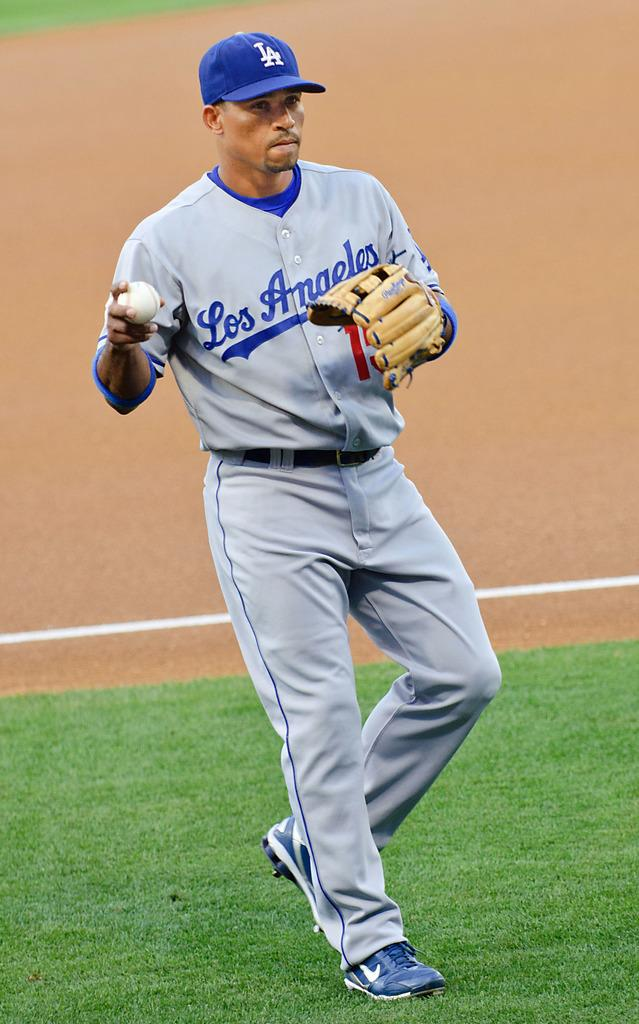<image>
Give a short and clear explanation of the subsequent image. A Los Angeles baseball player getting ready to throw the ball. 